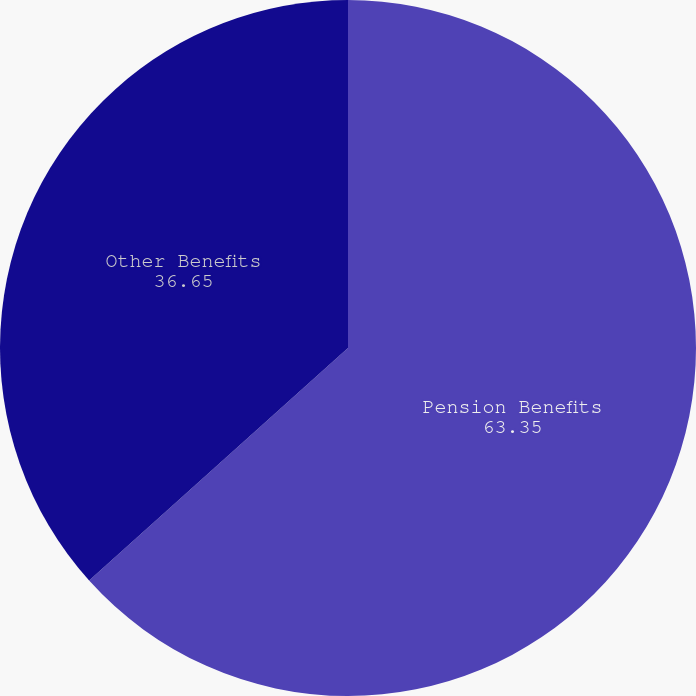Convert chart. <chart><loc_0><loc_0><loc_500><loc_500><pie_chart><fcel>Pension Benefits<fcel>Other Benefits<nl><fcel>63.35%<fcel>36.65%<nl></chart> 